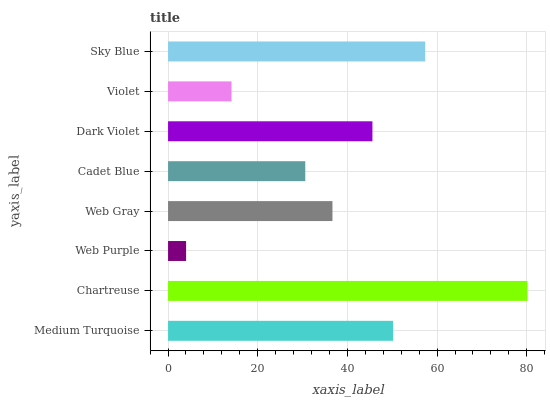Is Web Purple the minimum?
Answer yes or no. Yes. Is Chartreuse the maximum?
Answer yes or no. Yes. Is Chartreuse the minimum?
Answer yes or no. No. Is Web Purple the maximum?
Answer yes or no. No. Is Chartreuse greater than Web Purple?
Answer yes or no. Yes. Is Web Purple less than Chartreuse?
Answer yes or no. Yes. Is Web Purple greater than Chartreuse?
Answer yes or no. No. Is Chartreuse less than Web Purple?
Answer yes or no. No. Is Dark Violet the high median?
Answer yes or no. Yes. Is Web Gray the low median?
Answer yes or no. Yes. Is Web Gray the high median?
Answer yes or no. No. Is Violet the low median?
Answer yes or no. No. 